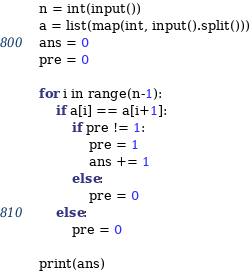Convert code to text. <code><loc_0><loc_0><loc_500><loc_500><_Python_>n = int(input())
a = list(map(int, input().split()))
ans = 0
pre = 0

for i in range(n-1):
    if a[i] == a[i+1]:
        if pre != 1:
            pre = 1
            ans += 1
        else:
            pre = 0
    else:
        pre = 0

print(ans)</code> 